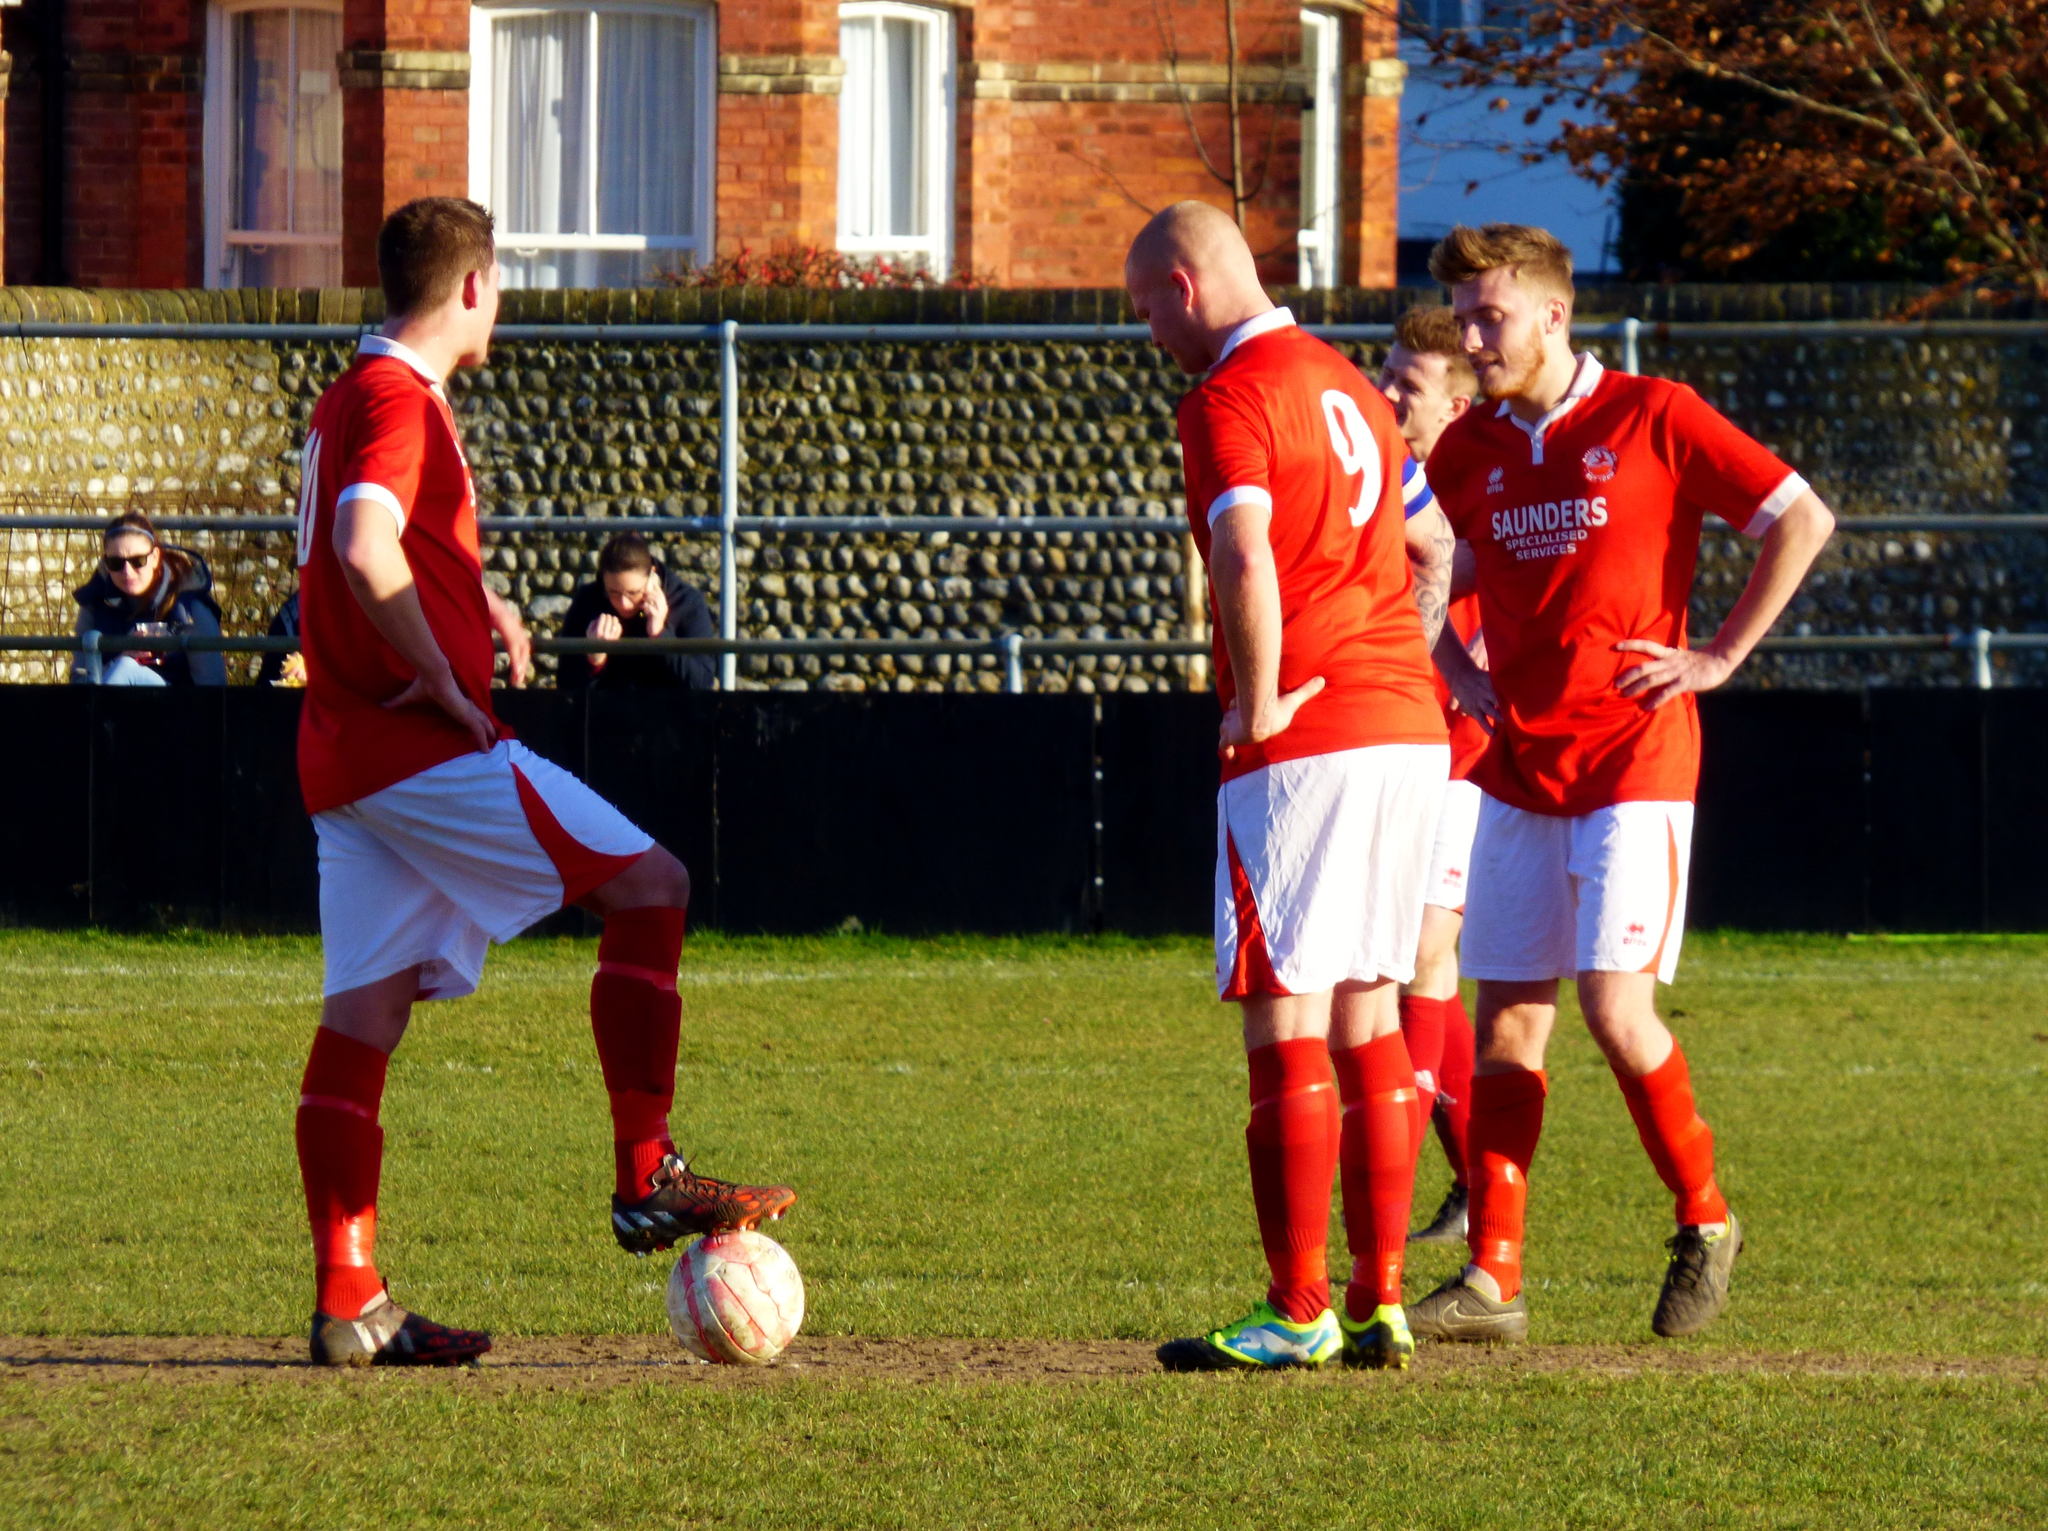<image>
Offer a succinct explanation of the picture presented. Three soccer players wearing red including one for number 9. 